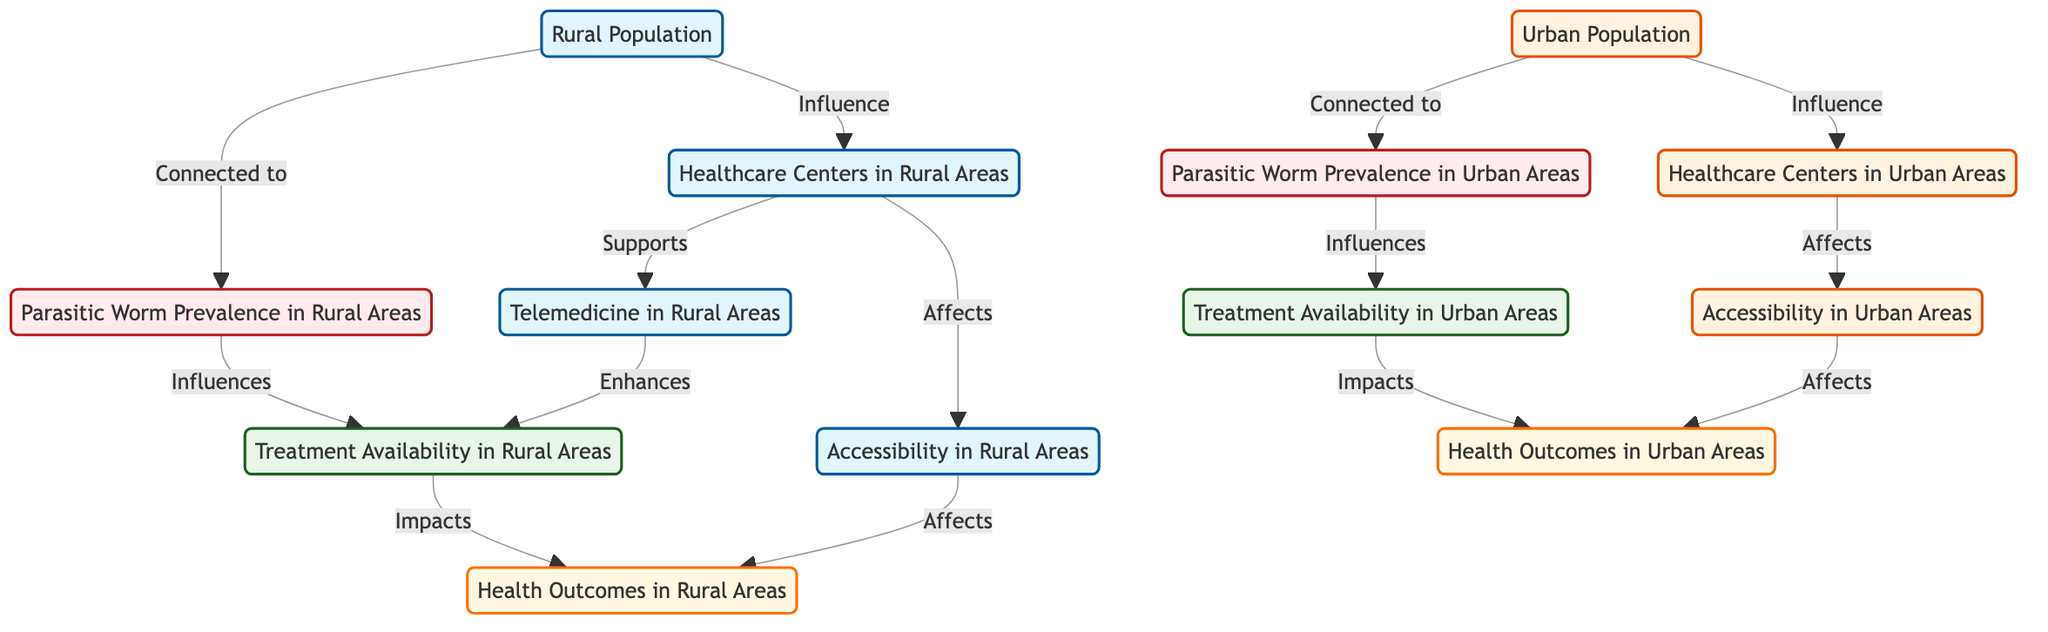What is the impact of healthcare centers in rural areas on accessibility? The diagram indicates that healthcare centers in rural areas affect accessibility in those areas. This means that as the number of healthcare centers increases, accessibility to treatment for parasitic worms also improves.
Answer: Affects How many nodes related to health outcomes are in the diagram? The diagram includes health outcomes in both rural and urban areas, making a total of two nodes related to health outcomes: one for rural and one for urban.
Answer: 2 What enhances treatment availability in rural areas? According to the diagram, telemedicine in rural areas enhances treatment availability in those areas. This shows that telemedicine plays a crucial role in improving access to treatment options.
Answer: Telemedicine How does parasitic worm prevalence in urban areas influence treatment availability? The diagram illustrates that parasitic worm prevalence in urban areas influences treatment availability in those areas, indicating that higher prevalence may lead to increased initiatives for treatment options.
Answer: Influences What is connected to rural population? The diagram shows that the rural population is connected to several nodes, including healthcare centers in rural areas and parasitic worm prevalence in rural areas, indicating a direct relationship with these concepts.
Answer: Healthcare Centers in Rural Areas, Parasitic Worm Prevalence in Rural Areas How does accessibility in urban areas affect health outcomes? The diagram demonstrates that accessibility in urban areas affects health outcomes, suggesting that improved accessibility directly contributes to better health outcomes in urban populations.
Answer: Affects What type of population is associated with healthcare centers in urban areas? The diagram specifies that the urban population is associated with healthcare centers in urban areas, indicating the focus on treatment availability and healthcare access for urban residents.
Answer: Urban Population What is a key difference between healthcare centers in rural versus urban areas? The diagram indicates that healthcare centers in rural areas and those in urban areas have different influences on accessibility, treatment availability, and health outcomes, highlighting a significant difference in how they operate.
Answer: Different influences 